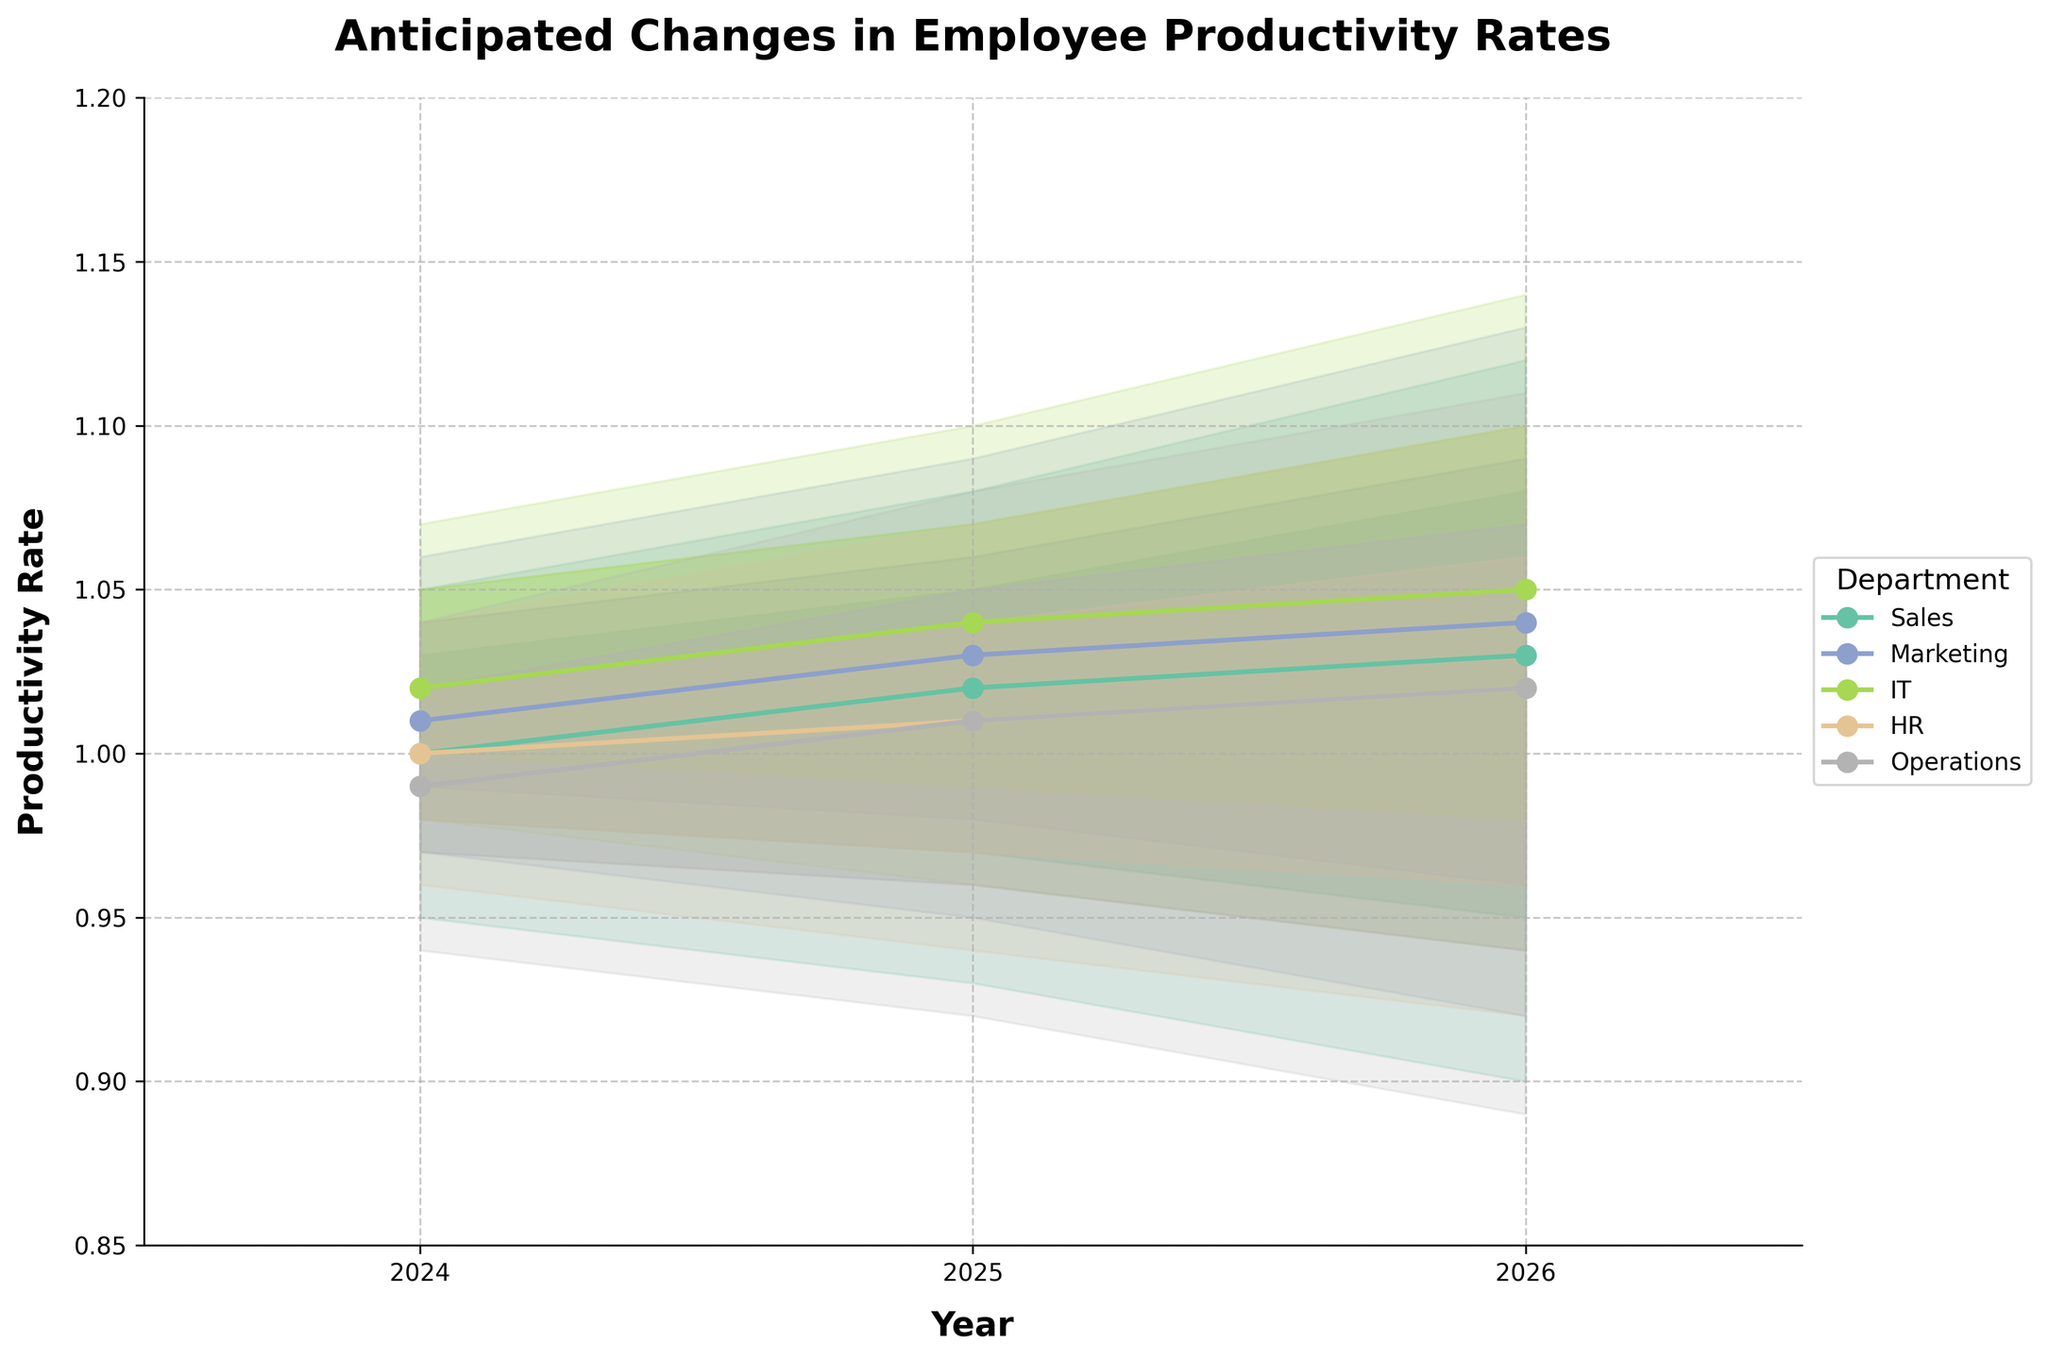What is the title of the figure? The title of the figure is usually placed at the top center or top left of the plot. In this case, it reads "Anticipated Changes in Employee Productivity Rates".
Answer: Anticipated Changes in Employee Productivity Rates Which department shows the highest mid productivity rate in 2026? Look for the "Mid" productivity points in 2026 for each department. Compare the values: Sales (1.03), Marketing (1.04), IT (1.05), HR (1.02), and Operations (1.02). The highest is IT with a value of 1.05.
Answer: IT In which year is the Sales department expected to have the lowest "Mid" productivity rate? Check the "Mid" productivity rates for the Sales department across the years. They are 1.00 (2024), 1.02 (2025), and 1.03 (2026). The lowest value is 1.00 in 2024.
Answer: 2024 How does the expected productivity rate trend for the HR department from 2024 to 2026? Observe the "Mid" values for the HR department over the years. The values are 1.00 (2024), 1.01 (2025), and 1.02 (2026). This indicates a gradual increase over the years.
Answer: Increasing Which department has the widest range of productivity rates in 2026? Calculate the range (difference between "High" and "Low") for each department in 2026. Sales (0.22), Marketing (0.21), IT (0.20), HR (0.18), Operations (0.22). Both Sales and Operations departments have the widest range of 0.22.
Answer: Sales and Operations Which department's productivity rate remains relatively stable over the years? Look for the department with the smallest fluctuation in "Mid" productivity rates over the years. IT's rates are 1.02 (2024), 1.04 (2025), and 1.05 (2026), showing minimal changes.
Answer: IT What is the average "Mid" productivity rate for the Marketing department? Calculate the average of the "Mid" values for Marketing: (1.01 (2024) + 1.03 (2025) + 1.04 (2026)) / 3 = 1.0267.
Answer: 1.03 Which two departments have the closest mid productivity rate in 2025? Compare the "Mid" values in 2025 for all departments: Sales (1.02), Marketing (1.03), IT (1.04), HR (1.01), Operations (1.01). HR and Operations both have a "Mid" value of 1.01 in 2025, making them the closest.
Answer: HR and Operations How does the productivity rate uncertainty vary between IT and Sales departments in 2024? Look at the range between "Low" and "High" for each department in 2024. Sales' range is 1.05 - 0.95 = 0.10, and IT's range is 1.07 - 0.98 = 0.09. Sales have a slightly larger uncertainty range.
Answer: Sales has higher uncertainty What trend can be observed in the productivity rates of the Operations department from 2024 to 2026? The "Mid" values for Operations are 0.99 (2024), 1.01 (2025), and 1.02 (2026). This suggests a steady increase in productivity rates over the years.
Answer: Increasing 